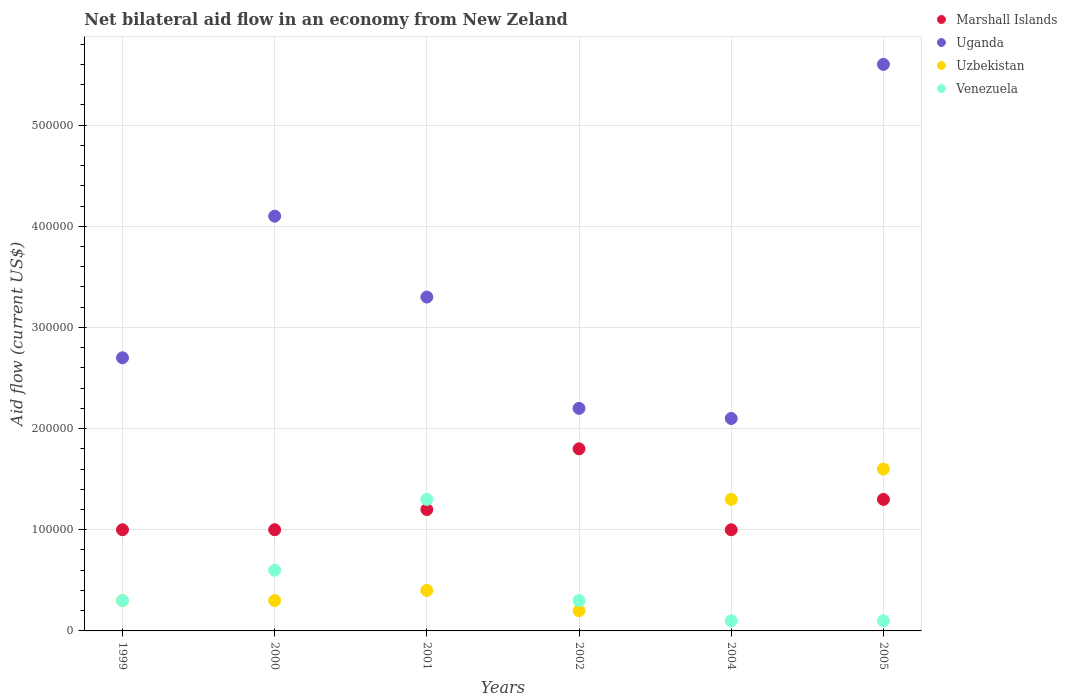Is the number of dotlines equal to the number of legend labels?
Provide a succinct answer. Yes. What is the net bilateral aid flow in Marshall Islands in 2000?
Provide a succinct answer. 1.00e+05. Across all years, what is the maximum net bilateral aid flow in Uganda?
Provide a short and direct response. 5.60e+05. Across all years, what is the minimum net bilateral aid flow in Uganda?
Your response must be concise. 2.10e+05. In which year was the net bilateral aid flow in Uganda maximum?
Offer a terse response. 2005. What is the difference between the net bilateral aid flow in Venezuela in 2000 and that in 2002?
Provide a short and direct response. 3.00e+04. What is the difference between the net bilateral aid flow in Marshall Islands in 2005 and the net bilateral aid flow in Venezuela in 2001?
Your answer should be very brief. 0. What is the average net bilateral aid flow in Uzbekistan per year?
Your response must be concise. 6.83e+04. In the year 2004, what is the difference between the net bilateral aid flow in Uzbekistan and net bilateral aid flow in Venezuela?
Give a very brief answer. 1.20e+05. What is the ratio of the net bilateral aid flow in Uganda in 2000 to that in 2004?
Your answer should be compact. 1.95. Is the net bilateral aid flow in Uzbekistan in 2001 less than that in 2002?
Keep it short and to the point. No. Is the difference between the net bilateral aid flow in Uzbekistan in 2002 and 2004 greater than the difference between the net bilateral aid flow in Venezuela in 2002 and 2004?
Provide a short and direct response. No. What is the difference between the highest and the lowest net bilateral aid flow in Marshall Islands?
Provide a short and direct response. 8.00e+04. Is the net bilateral aid flow in Uganda strictly less than the net bilateral aid flow in Marshall Islands over the years?
Ensure brevity in your answer.  No. How many years are there in the graph?
Provide a succinct answer. 6. Are the values on the major ticks of Y-axis written in scientific E-notation?
Ensure brevity in your answer.  No. How many legend labels are there?
Keep it short and to the point. 4. How are the legend labels stacked?
Give a very brief answer. Vertical. What is the title of the graph?
Give a very brief answer. Net bilateral aid flow in an economy from New Zeland. What is the label or title of the X-axis?
Your response must be concise. Years. What is the Aid flow (current US$) of Marshall Islands in 1999?
Provide a succinct answer. 1.00e+05. What is the Aid flow (current US$) in Uganda in 1999?
Your answer should be very brief. 2.70e+05. What is the Aid flow (current US$) in Venezuela in 1999?
Offer a terse response. 3.00e+04. What is the Aid flow (current US$) in Uganda in 2000?
Make the answer very short. 4.10e+05. What is the Aid flow (current US$) of Venezuela in 2000?
Your answer should be very brief. 6.00e+04. What is the Aid flow (current US$) of Marshall Islands in 2001?
Ensure brevity in your answer.  1.20e+05. What is the Aid flow (current US$) of Uzbekistan in 2001?
Your response must be concise. 4.00e+04. What is the Aid flow (current US$) of Venezuela in 2001?
Offer a very short reply. 1.30e+05. What is the Aid flow (current US$) in Marshall Islands in 2002?
Offer a very short reply. 1.80e+05. What is the Aid flow (current US$) in Uzbekistan in 2002?
Provide a short and direct response. 2.00e+04. What is the Aid flow (current US$) of Venezuela in 2002?
Your answer should be compact. 3.00e+04. What is the Aid flow (current US$) in Marshall Islands in 2005?
Provide a short and direct response. 1.30e+05. What is the Aid flow (current US$) of Uganda in 2005?
Your answer should be compact. 5.60e+05. Across all years, what is the maximum Aid flow (current US$) of Marshall Islands?
Keep it short and to the point. 1.80e+05. Across all years, what is the maximum Aid flow (current US$) of Uganda?
Provide a short and direct response. 5.60e+05. Across all years, what is the maximum Aid flow (current US$) of Uzbekistan?
Your answer should be compact. 1.60e+05. Across all years, what is the minimum Aid flow (current US$) in Uganda?
Offer a terse response. 2.10e+05. Across all years, what is the minimum Aid flow (current US$) of Uzbekistan?
Keep it short and to the point. 2.00e+04. What is the total Aid flow (current US$) in Marshall Islands in the graph?
Your answer should be compact. 7.30e+05. What is the total Aid flow (current US$) in Uganda in the graph?
Provide a short and direct response. 2.00e+06. What is the total Aid flow (current US$) in Uzbekistan in the graph?
Provide a short and direct response. 4.10e+05. What is the difference between the Aid flow (current US$) of Marshall Islands in 1999 and that in 2000?
Ensure brevity in your answer.  0. What is the difference between the Aid flow (current US$) of Uzbekistan in 1999 and that in 2000?
Keep it short and to the point. 0. What is the difference between the Aid flow (current US$) of Marshall Islands in 1999 and that in 2001?
Your response must be concise. -2.00e+04. What is the difference between the Aid flow (current US$) in Uganda in 1999 and that in 2001?
Your answer should be very brief. -6.00e+04. What is the difference between the Aid flow (current US$) of Venezuela in 1999 and that in 2001?
Offer a very short reply. -1.00e+05. What is the difference between the Aid flow (current US$) of Uganda in 1999 and that in 2002?
Provide a succinct answer. 5.00e+04. What is the difference between the Aid flow (current US$) of Uzbekistan in 1999 and that in 2004?
Provide a short and direct response. -1.00e+05. What is the difference between the Aid flow (current US$) in Venezuela in 1999 and that in 2004?
Keep it short and to the point. 2.00e+04. What is the difference between the Aid flow (current US$) in Uzbekistan in 1999 and that in 2005?
Offer a terse response. -1.30e+05. What is the difference between the Aid flow (current US$) in Venezuela in 1999 and that in 2005?
Your answer should be very brief. 2.00e+04. What is the difference between the Aid flow (current US$) in Marshall Islands in 2000 and that in 2001?
Your response must be concise. -2.00e+04. What is the difference between the Aid flow (current US$) of Uzbekistan in 2000 and that in 2001?
Offer a very short reply. -10000. What is the difference between the Aid flow (current US$) of Venezuela in 2000 and that in 2001?
Your response must be concise. -7.00e+04. What is the difference between the Aid flow (current US$) in Marshall Islands in 2000 and that in 2002?
Provide a short and direct response. -8.00e+04. What is the difference between the Aid flow (current US$) of Uzbekistan in 2000 and that in 2002?
Keep it short and to the point. 10000. What is the difference between the Aid flow (current US$) of Marshall Islands in 2000 and that in 2004?
Offer a very short reply. 0. What is the difference between the Aid flow (current US$) in Uganda in 2000 and that in 2004?
Your answer should be very brief. 2.00e+05. What is the difference between the Aid flow (current US$) in Uzbekistan in 2000 and that in 2004?
Provide a short and direct response. -1.00e+05. What is the difference between the Aid flow (current US$) of Uganda in 2000 and that in 2005?
Offer a terse response. -1.50e+05. What is the difference between the Aid flow (current US$) in Venezuela in 2000 and that in 2005?
Your answer should be very brief. 5.00e+04. What is the difference between the Aid flow (current US$) of Marshall Islands in 2001 and that in 2002?
Keep it short and to the point. -6.00e+04. What is the difference between the Aid flow (current US$) in Uganda in 2001 and that in 2002?
Your answer should be compact. 1.10e+05. What is the difference between the Aid flow (current US$) in Uzbekistan in 2001 and that in 2004?
Your response must be concise. -9.00e+04. What is the difference between the Aid flow (current US$) in Uganda in 2001 and that in 2005?
Your response must be concise. -2.30e+05. What is the difference between the Aid flow (current US$) in Uzbekistan in 2001 and that in 2005?
Make the answer very short. -1.20e+05. What is the difference between the Aid flow (current US$) in Marshall Islands in 2002 and that in 2004?
Give a very brief answer. 8.00e+04. What is the difference between the Aid flow (current US$) in Uganda in 2002 and that in 2004?
Ensure brevity in your answer.  10000. What is the difference between the Aid flow (current US$) of Uganda in 2002 and that in 2005?
Your response must be concise. -3.40e+05. What is the difference between the Aid flow (current US$) in Uzbekistan in 2002 and that in 2005?
Provide a succinct answer. -1.40e+05. What is the difference between the Aid flow (current US$) of Marshall Islands in 2004 and that in 2005?
Offer a terse response. -3.00e+04. What is the difference between the Aid flow (current US$) in Uganda in 2004 and that in 2005?
Offer a terse response. -3.50e+05. What is the difference between the Aid flow (current US$) of Uzbekistan in 2004 and that in 2005?
Your answer should be compact. -3.00e+04. What is the difference between the Aid flow (current US$) of Marshall Islands in 1999 and the Aid flow (current US$) of Uganda in 2000?
Make the answer very short. -3.10e+05. What is the difference between the Aid flow (current US$) of Uganda in 1999 and the Aid flow (current US$) of Venezuela in 2000?
Your answer should be very brief. 2.10e+05. What is the difference between the Aid flow (current US$) of Uzbekistan in 1999 and the Aid flow (current US$) of Venezuela in 2000?
Keep it short and to the point. -3.00e+04. What is the difference between the Aid flow (current US$) of Marshall Islands in 1999 and the Aid flow (current US$) of Uzbekistan in 2001?
Offer a very short reply. 6.00e+04. What is the difference between the Aid flow (current US$) in Uganda in 1999 and the Aid flow (current US$) in Venezuela in 2001?
Your answer should be very brief. 1.40e+05. What is the difference between the Aid flow (current US$) of Marshall Islands in 1999 and the Aid flow (current US$) of Uganda in 2002?
Offer a very short reply. -1.20e+05. What is the difference between the Aid flow (current US$) of Marshall Islands in 1999 and the Aid flow (current US$) of Venezuela in 2002?
Keep it short and to the point. 7.00e+04. What is the difference between the Aid flow (current US$) in Uganda in 1999 and the Aid flow (current US$) in Venezuela in 2002?
Your answer should be compact. 2.40e+05. What is the difference between the Aid flow (current US$) in Marshall Islands in 1999 and the Aid flow (current US$) in Uganda in 2004?
Offer a very short reply. -1.10e+05. What is the difference between the Aid flow (current US$) of Uganda in 1999 and the Aid flow (current US$) of Uzbekistan in 2004?
Your answer should be very brief. 1.40e+05. What is the difference between the Aid flow (current US$) of Uganda in 1999 and the Aid flow (current US$) of Venezuela in 2004?
Make the answer very short. 2.60e+05. What is the difference between the Aid flow (current US$) in Marshall Islands in 1999 and the Aid flow (current US$) in Uganda in 2005?
Ensure brevity in your answer.  -4.60e+05. What is the difference between the Aid flow (current US$) of Marshall Islands in 1999 and the Aid flow (current US$) of Uzbekistan in 2005?
Your answer should be very brief. -6.00e+04. What is the difference between the Aid flow (current US$) in Marshall Islands in 1999 and the Aid flow (current US$) in Venezuela in 2005?
Keep it short and to the point. 9.00e+04. What is the difference between the Aid flow (current US$) in Uzbekistan in 1999 and the Aid flow (current US$) in Venezuela in 2005?
Provide a succinct answer. 2.00e+04. What is the difference between the Aid flow (current US$) of Marshall Islands in 2000 and the Aid flow (current US$) of Uganda in 2001?
Provide a short and direct response. -2.30e+05. What is the difference between the Aid flow (current US$) of Uganda in 2000 and the Aid flow (current US$) of Uzbekistan in 2001?
Provide a short and direct response. 3.70e+05. What is the difference between the Aid flow (current US$) of Uzbekistan in 2000 and the Aid flow (current US$) of Venezuela in 2001?
Your answer should be compact. -1.00e+05. What is the difference between the Aid flow (current US$) of Marshall Islands in 2000 and the Aid flow (current US$) of Uganda in 2002?
Ensure brevity in your answer.  -1.20e+05. What is the difference between the Aid flow (current US$) in Marshall Islands in 2000 and the Aid flow (current US$) in Uzbekistan in 2002?
Provide a short and direct response. 8.00e+04. What is the difference between the Aid flow (current US$) in Marshall Islands in 2000 and the Aid flow (current US$) in Uganda in 2004?
Offer a very short reply. -1.10e+05. What is the difference between the Aid flow (current US$) in Uganda in 2000 and the Aid flow (current US$) in Venezuela in 2004?
Your answer should be compact. 4.00e+05. What is the difference between the Aid flow (current US$) in Uzbekistan in 2000 and the Aid flow (current US$) in Venezuela in 2004?
Ensure brevity in your answer.  2.00e+04. What is the difference between the Aid flow (current US$) of Marshall Islands in 2000 and the Aid flow (current US$) of Uganda in 2005?
Provide a short and direct response. -4.60e+05. What is the difference between the Aid flow (current US$) of Marshall Islands in 2000 and the Aid flow (current US$) of Venezuela in 2005?
Keep it short and to the point. 9.00e+04. What is the difference between the Aid flow (current US$) of Uganda in 2000 and the Aid flow (current US$) of Uzbekistan in 2005?
Offer a very short reply. 2.50e+05. What is the difference between the Aid flow (current US$) in Uganda in 2000 and the Aid flow (current US$) in Venezuela in 2005?
Keep it short and to the point. 4.00e+05. What is the difference between the Aid flow (current US$) in Uzbekistan in 2000 and the Aid flow (current US$) in Venezuela in 2005?
Provide a succinct answer. 2.00e+04. What is the difference between the Aid flow (current US$) in Marshall Islands in 2001 and the Aid flow (current US$) in Uganda in 2002?
Provide a short and direct response. -1.00e+05. What is the difference between the Aid flow (current US$) in Marshall Islands in 2001 and the Aid flow (current US$) in Uzbekistan in 2002?
Offer a very short reply. 1.00e+05. What is the difference between the Aid flow (current US$) of Uganda in 2001 and the Aid flow (current US$) of Venezuela in 2002?
Your response must be concise. 3.00e+05. What is the difference between the Aid flow (current US$) in Uzbekistan in 2001 and the Aid flow (current US$) in Venezuela in 2002?
Your answer should be very brief. 10000. What is the difference between the Aid flow (current US$) in Marshall Islands in 2001 and the Aid flow (current US$) in Uganda in 2004?
Offer a very short reply. -9.00e+04. What is the difference between the Aid flow (current US$) in Marshall Islands in 2001 and the Aid flow (current US$) in Uzbekistan in 2004?
Your answer should be compact. -10000. What is the difference between the Aid flow (current US$) in Uganda in 2001 and the Aid flow (current US$) in Venezuela in 2004?
Offer a terse response. 3.20e+05. What is the difference between the Aid flow (current US$) of Marshall Islands in 2001 and the Aid flow (current US$) of Uganda in 2005?
Ensure brevity in your answer.  -4.40e+05. What is the difference between the Aid flow (current US$) of Marshall Islands in 2001 and the Aid flow (current US$) of Uzbekistan in 2005?
Your answer should be compact. -4.00e+04. What is the difference between the Aid flow (current US$) of Uganda in 2001 and the Aid flow (current US$) of Uzbekistan in 2005?
Your answer should be compact. 1.70e+05. What is the difference between the Aid flow (current US$) in Uzbekistan in 2001 and the Aid flow (current US$) in Venezuela in 2005?
Give a very brief answer. 3.00e+04. What is the difference between the Aid flow (current US$) in Marshall Islands in 2002 and the Aid flow (current US$) in Uganda in 2004?
Your answer should be very brief. -3.00e+04. What is the difference between the Aid flow (current US$) in Marshall Islands in 2002 and the Aid flow (current US$) in Uzbekistan in 2004?
Provide a short and direct response. 5.00e+04. What is the difference between the Aid flow (current US$) of Marshall Islands in 2002 and the Aid flow (current US$) of Venezuela in 2004?
Your response must be concise. 1.70e+05. What is the difference between the Aid flow (current US$) of Uganda in 2002 and the Aid flow (current US$) of Venezuela in 2004?
Your answer should be very brief. 2.10e+05. What is the difference between the Aid flow (current US$) in Uzbekistan in 2002 and the Aid flow (current US$) in Venezuela in 2004?
Provide a short and direct response. 10000. What is the difference between the Aid flow (current US$) in Marshall Islands in 2002 and the Aid flow (current US$) in Uganda in 2005?
Ensure brevity in your answer.  -3.80e+05. What is the difference between the Aid flow (current US$) in Uganda in 2002 and the Aid flow (current US$) in Uzbekistan in 2005?
Offer a very short reply. 6.00e+04. What is the difference between the Aid flow (current US$) of Uganda in 2002 and the Aid flow (current US$) of Venezuela in 2005?
Offer a terse response. 2.10e+05. What is the difference between the Aid flow (current US$) of Uzbekistan in 2002 and the Aid flow (current US$) of Venezuela in 2005?
Make the answer very short. 10000. What is the difference between the Aid flow (current US$) of Marshall Islands in 2004 and the Aid flow (current US$) of Uganda in 2005?
Offer a terse response. -4.60e+05. What is the difference between the Aid flow (current US$) of Marshall Islands in 2004 and the Aid flow (current US$) of Venezuela in 2005?
Offer a very short reply. 9.00e+04. What is the difference between the Aid flow (current US$) in Uganda in 2004 and the Aid flow (current US$) in Uzbekistan in 2005?
Keep it short and to the point. 5.00e+04. What is the difference between the Aid flow (current US$) of Uganda in 2004 and the Aid flow (current US$) of Venezuela in 2005?
Provide a succinct answer. 2.00e+05. What is the difference between the Aid flow (current US$) in Uzbekistan in 2004 and the Aid flow (current US$) in Venezuela in 2005?
Your response must be concise. 1.20e+05. What is the average Aid flow (current US$) of Marshall Islands per year?
Offer a terse response. 1.22e+05. What is the average Aid flow (current US$) of Uganda per year?
Provide a succinct answer. 3.33e+05. What is the average Aid flow (current US$) of Uzbekistan per year?
Keep it short and to the point. 6.83e+04. What is the average Aid flow (current US$) in Venezuela per year?
Provide a short and direct response. 4.50e+04. In the year 1999, what is the difference between the Aid flow (current US$) of Uganda and Aid flow (current US$) of Uzbekistan?
Keep it short and to the point. 2.40e+05. In the year 2000, what is the difference between the Aid flow (current US$) of Marshall Islands and Aid flow (current US$) of Uganda?
Provide a short and direct response. -3.10e+05. In the year 2000, what is the difference between the Aid flow (current US$) of Marshall Islands and Aid flow (current US$) of Venezuela?
Offer a very short reply. 4.00e+04. In the year 2000, what is the difference between the Aid flow (current US$) in Uganda and Aid flow (current US$) in Uzbekistan?
Offer a very short reply. 3.80e+05. In the year 2001, what is the difference between the Aid flow (current US$) of Marshall Islands and Aid flow (current US$) of Uganda?
Offer a very short reply. -2.10e+05. In the year 2001, what is the difference between the Aid flow (current US$) of Marshall Islands and Aid flow (current US$) of Uzbekistan?
Offer a terse response. 8.00e+04. In the year 2001, what is the difference between the Aid flow (current US$) of Marshall Islands and Aid flow (current US$) of Venezuela?
Provide a succinct answer. -10000. In the year 2001, what is the difference between the Aid flow (current US$) of Uganda and Aid flow (current US$) of Uzbekistan?
Offer a very short reply. 2.90e+05. In the year 2002, what is the difference between the Aid flow (current US$) of Marshall Islands and Aid flow (current US$) of Uzbekistan?
Provide a short and direct response. 1.60e+05. In the year 2002, what is the difference between the Aid flow (current US$) in Uganda and Aid flow (current US$) in Venezuela?
Keep it short and to the point. 1.90e+05. In the year 2004, what is the difference between the Aid flow (current US$) in Marshall Islands and Aid flow (current US$) in Uganda?
Keep it short and to the point. -1.10e+05. In the year 2004, what is the difference between the Aid flow (current US$) in Marshall Islands and Aid flow (current US$) in Uzbekistan?
Keep it short and to the point. -3.00e+04. In the year 2004, what is the difference between the Aid flow (current US$) of Marshall Islands and Aid flow (current US$) of Venezuela?
Offer a terse response. 9.00e+04. In the year 2004, what is the difference between the Aid flow (current US$) of Uganda and Aid flow (current US$) of Venezuela?
Make the answer very short. 2.00e+05. In the year 2005, what is the difference between the Aid flow (current US$) of Marshall Islands and Aid flow (current US$) of Uganda?
Your answer should be very brief. -4.30e+05. In the year 2005, what is the difference between the Aid flow (current US$) in Marshall Islands and Aid flow (current US$) in Uzbekistan?
Your answer should be very brief. -3.00e+04. In the year 2005, what is the difference between the Aid flow (current US$) in Marshall Islands and Aid flow (current US$) in Venezuela?
Provide a short and direct response. 1.20e+05. In the year 2005, what is the difference between the Aid flow (current US$) of Uganda and Aid flow (current US$) of Uzbekistan?
Keep it short and to the point. 4.00e+05. In the year 2005, what is the difference between the Aid flow (current US$) in Uzbekistan and Aid flow (current US$) in Venezuela?
Give a very brief answer. 1.50e+05. What is the ratio of the Aid flow (current US$) in Marshall Islands in 1999 to that in 2000?
Your response must be concise. 1. What is the ratio of the Aid flow (current US$) in Uganda in 1999 to that in 2000?
Provide a succinct answer. 0.66. What is the ratio of the Aid flow (current US$) of Uzbekistan in 1999 to that in 2000?
Offer a very short reply. 1. What is the ratio of the Aid flow (current US$) of Venezuela in 1999 to that in 2000?
Provide a short and direct response. 0.5. What is the ratio of the Aid flow (current US$) in Marshall Islands in 1999 to that in 2001?
Ensure brevity in your answer.  0.83. What is the ratio of the Aid flow (current US$) in Uganda in 1999 to that in 2001?
Your response must be concise. 0.82. What is the ratio of the Aid flow (current US$) of Venezuela in 1999 to that in 2001?
Your answer should be compact. 0.23. What is the ratio of the Aid flow (current US$) in Marshall Islands in 1999 to that in 2002?
Provide a succinct answer. 0.56. What is the ratio of the Aid flow (current US$) in Uganda in 1999 to that in 2002?
Your answer should be very brief. 1.23. What is the ratio of the Aid flow (current US$) of Venezuela in 1999 to that in 2002?
Keep it short and to the point. 1. What is the ratio of the Aid flow (current US$) in Uganda in 1999 to that in 2004?
Keep it short and to the point. 1.29. What is the ratio of the Aid flow (current US$) in Uzbekistan in 1999 to that in 2004?
Offer a very short reply. 0.23. What is the ratio of the Aid flow (current US$) in Marshall Islands in 1999 to that in 2005?
Provide a short and direct response. 0.77. What is the ratio of the Aid flow (current US$) in Uganda in 1999 to that in 2005?
Make the answer very short. 0.48. What is the ratio of the Aid flow (current US$) of Uzbekistan in 1999 to that in 2005?
Your answer should be compact. 0.19. What is the ratio of the Aid flow (current US$) of Venezuela in 1999 to that in 2005?
Make the answer very short. 3. What is the ratio of the Aid flow (current US$) in Uganda in 2000 to that in 2001?
Give a very brief answer. 1.24. What is the ratio of the Aid flow (current US$) of Uzbekistan in 2000 to that in 2001?
Make the answer very short. 0.75. What is the ratio of the Aid flow (current US$) of Venezuela in 2000 to that in 2001?
Give a very brief answer. 0.46. What is the ratio of the Aid flow (current US$) of Marshall Islands in 2000 to that in 2002?
Your response must be concise. 0.56. What is the ratio of the Aid flow (current US$) in Uganda in 2000 to that in 2002?
Provide a short and direct response. 1.86. What is the ratio of the Aid flow (current US$) of Venezuela in 2000 to that in 2002?
Keep it short and to the point. 2. What is the ratio of the Aid flow (current US$) in Marshall Islands in 2000 to that in 2004?
Your answer should be very brief. 1. What is the ratio of the Aid flow (current US$) in Uganda in 2000 to that in 2004?
Make the answer very short. 1.95. What is the ratio of the Aid flow (current US$) of Uzbekistan in 2000 to that in 2004?
Offer a very short reply. 0.23. What is the ratio of the Aid flow (current US$) of Venezuela in 2000 to that in 2004?
Provide a short and direct response. 6. What is the ratio of the Aid flow (current US$) in Marshall Islands in 2000 to that in 2005?
Your answer should be compact. 0.77. What is the ratio of the Aid flow (current US$) in Uganda in 2000 to that in 2005?
Offer a terse response. 0.73. What is the ratio of the Aid flow (current US$) in Uzbekistan in 2000 to that in 2005?
Provide a succinct answer. 0.19. What is the ratio of the Aid flow (current US$) of Venezuela in 2000 to that in 2005?
Keep it short and to the point. 6. What is the ratio of the Aid flow (current US$) of Venezuela in 2001 to that in 2002?
Your answer should be compact. 4.33. What is the ratio of the Aid flow (current US$) in Marshall Islands in 2001 to that in 2004?
Provide a succinct answer. 1.2. What is the ratio of the Aid flow (current US$) of Uganda in 2001 to that in 2004?
Give a very brief answer. 1.57. What is the ratio of the Aid flow (current US$) of Uzbekistan in 2001 to that in 2004?
Make the answer very short. 0.31. What is the ratio of the Aid flow (current US$) in Venezuela in 2001 to that in 2004?
Make the answer very short. 13. What is the ratio of the Aid flow (current US$) in Uganda in 2001 to that in 2005?
Provide a short and direct response. 0.59. What is the ratio of the Aid flow (current US$) in Venezuela in 2001 to that in 2005?
Keep it short and to the point. 13. What is the ratio of the Aid flow (current US$) in Marshall Islands in 2002 to that in 2004?
Your answer should be compact. 1.8. What is the ratio of the Aid flow (current US$) in Uganda in 2002 to that in 2004?
Offer a very short reply. 1.05. What is the ratio of the Aid flow (current US$) of Uzbekistan in 2002 to that in 2004?
Provide a succinct answer. 0.15. What is the ratio of the Aid flow (current US$) in Marshall Islands in 2002 to that in 2005?
Provide a short and direct response. 1.38. What is the ratio of the Aid flow (current US$) in Uganda in 2002 to that in 2005?
Your response must be concise. 0.39. What is the ratio of the Aid flow (current US$) in Venezuela in 2002 to that in 2005?
Your response must be concise. 3. What is the ratio of the Aid flow (current US$) in Marshall Islands in 2004 to that in 2005?
Provide a succinct answer. 0.77. What is the ratio of the Aid flow (current US$) in Uganda in 2004 to that in 2005?
Give a very brief answer. 0.38. What is the ratio of the Aid flow (current US$) in Uzbekistan in 2004 to that in 2005?
Keep it short and to the point. 0.81. What is the difference between the highest and the second highest Aid flow (current US$) of Marshall Islands?
Offer a very short reply. 5.00e+04. What is the difference between the highest and the second highest Aid flow (current US$) of Uzbekistan?
Provide a succinct answer. 3.00e+04. 